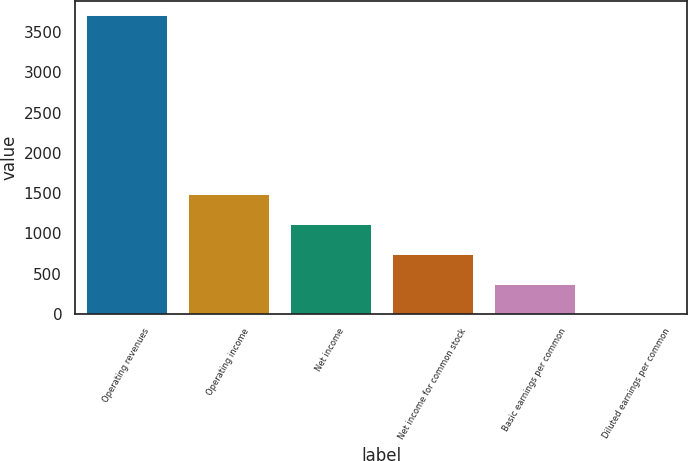Convert chart to OTSL. <chart><loc_0><loc_0><loc_500><loc_500><bar_chart><fcel>Operating revenues<fcel>Operating income<fcel>Net income<fcel>Net income for common stock<fcel>Basic earnings per common<fcel>Diluted earnings per common<nl><fcel>3707<fcel>1483.55<fcel>1112.97<fcel>742.39<fcel>371.81<fcel>1.23<nl></chart> 